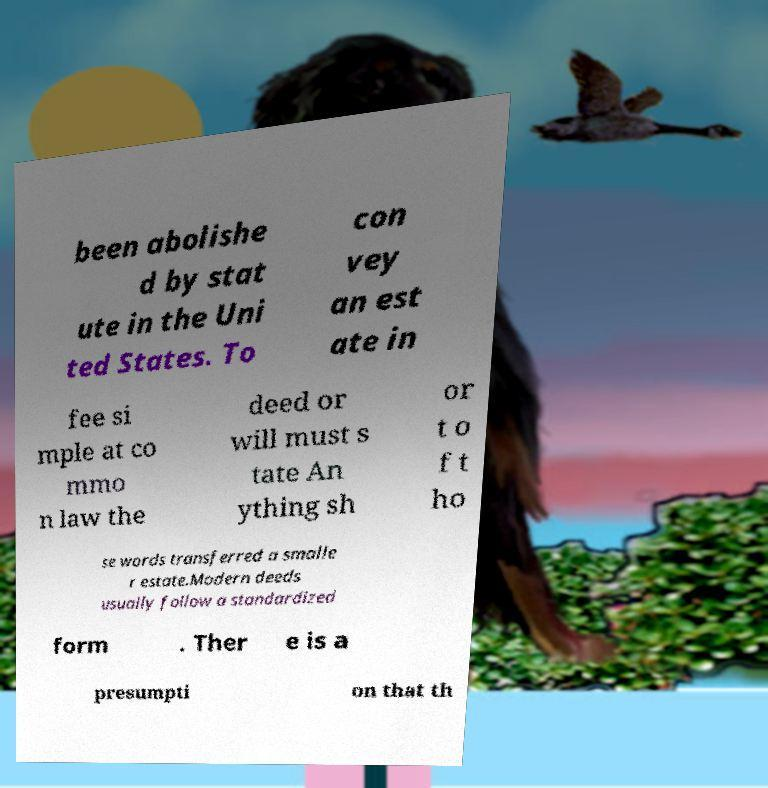Please identify and transcribe the text found in this image. been abolishe d by stat ute in the Uni ted States. To con vey an est ate in fee si mple at co mmo n law the deed or will must s tate An ything sh or t o f t ho se words transferred a smalle r estate.Modern deeds usually follow a standardized form . Ther e is a presumpti on that th 